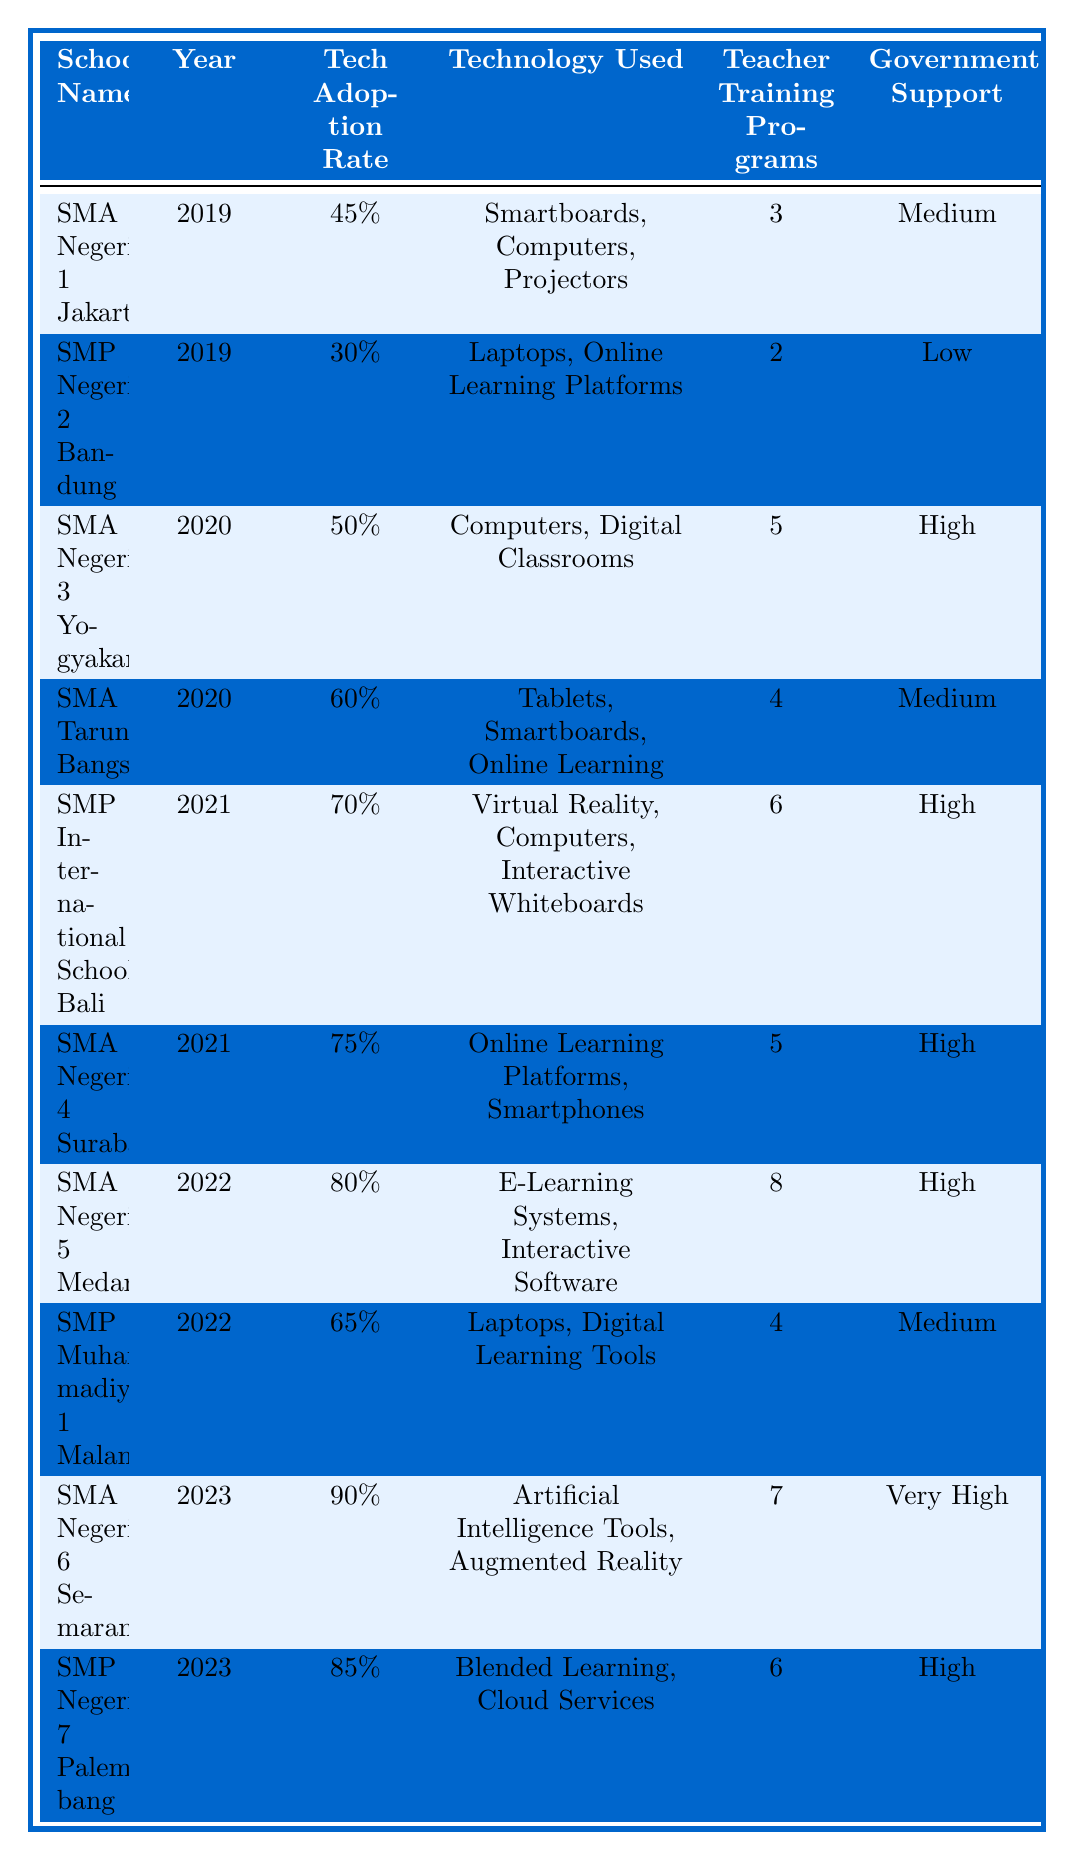What was the Technology Adoption Rate for SMA Negeri 1 Jakarta in 2019? The table lists SMA Negeri 1 Jakarta under the year 2019 with a Technology Adoption Rate of 45%.
Answer: 45% Which school had the highest Technology Adoption Rate in 2023? SMA Negeri 6 Semarang is listed as having the highest Technology Adoption Rate of 90% for the year 2023.
Answer: SMA Negeri 6 Semarang What are the technology tools used by SMP International School Bali in 2021? The table specifies that in 2021, SMP International School Bali used Virtual Reality, Computers, and Interactive Whiteboards.
Answer: Virtual Reality, Computers, Interactive Whiteboards How many Teacher Training Programs were associated with SMA Negeri 5 Medan in 2022? The table indicates that SMA Negeri 5 Medan had 8 Teacher Training Programs in the year 2022.
Answer: 8 What was the average Technology Adoption Rate for the years 2020 and 2021? The Technology Adoption Rates for 2020 are 50% and 60%, and for 2021 are 70% and 75%. The average is calculated as (50 + 60 + 70 + 75) / 4 = 63.75%.
Answer: 63.75% Did SMA Taruna Bangsa receive High level Government Support in 2020? According to the table, SMA Taruna Bangsa received Medium level Government Support, not High.
Answer: No Which school experienced an increase in Technology Adoption Rate from 2021 to 2022? The table shows that SMA Negeri 5 Medan increased its Technology Adoption Rate from 75% in 2021 to 80% in 2022.
Answer: SMA Negeri 5 Medan What percentage of Government Support does SMP Negeri 7 Palembang have in 2023? The table lists that SMP Negeri 7 Palembang has High level Government Support for the year 2023.
Answer: High What is the difference in Technology Adoption Rates between SMA Negeri 4 Surabaya (2021) and SMA Negeri 6 Semarang (2023)? SMA Negeri 4 Surabaya had a Technology Adoption Rate of 75% in 2021, while SMA Negeri 6 Semarang had 90% in 2023. The difference is 90% - 75% = 15%.
Answer: 15% Which school had both a Technology Adoption Rate of over 80% and Very High Government Support in 2023? The table indicates that only SMA Negeri 6 Semarang had an adoption rate of 90% and Very High Government Support in 2023.
Answer: SMA Negeri 6 Semarang 